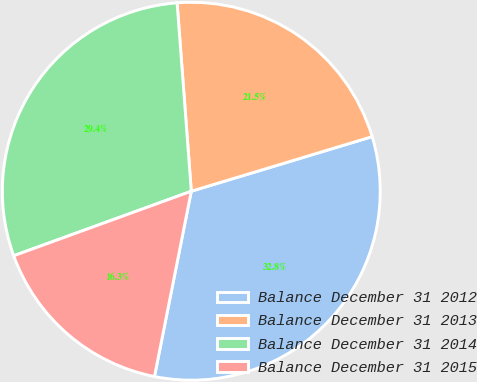Convert chart to OTSL. <chart><loc_0><loc_0><loc_500><loc_500><pie_chart><fcel>Balance December 31 2012<fcel>Balance December 31 2013<fcel>Balance December 31 2014<fcel>Balance December 31 2015<nl><fcel>32.79%<fcel>21.53%<fcel>29.35%<fcel>16.33%<nl></chart> 